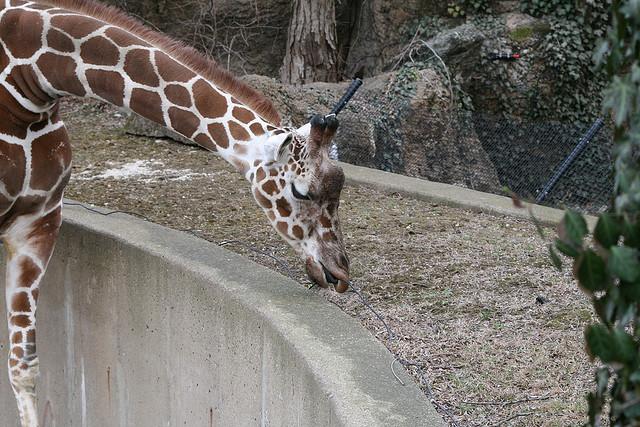Does this giraffe appear to be in a zoo?
Give a very brief answer. Yes. Is the giraffe standing upright?
Be succinct. No. Does the giraffe have a mohawk?
Be succinct. No. 